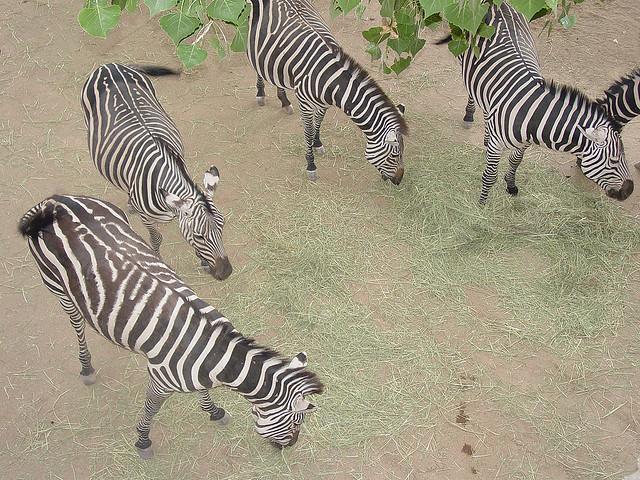How many zebras are there?
Give a very brief answer. 5. How many zebra's are grazing on grass?
Give a very brief answer. 5. How many zebras can be seen?
Give a very brief answer. 4. 